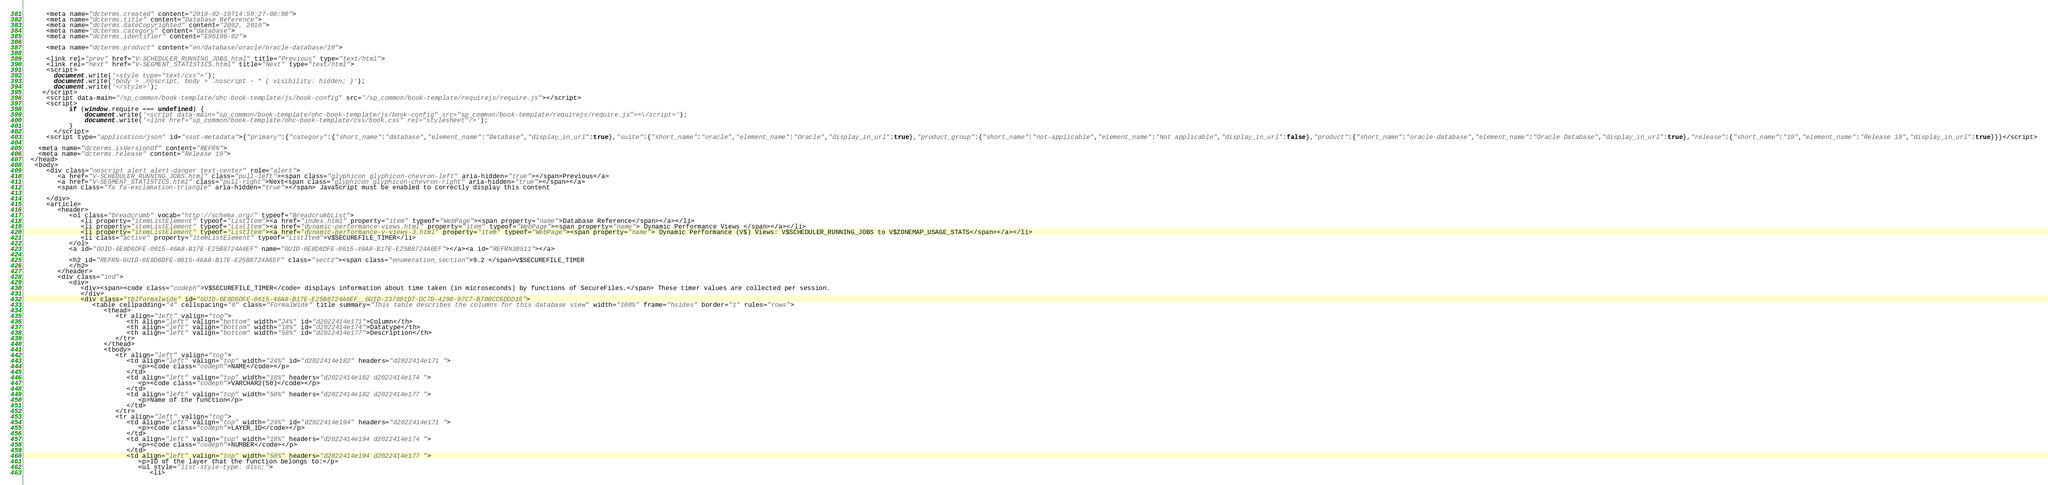<code> <loc_0><loc_0><loc_500><loc_500><_HTML_>      <meta name="dcterms.created" content="2019-02-10T14:59:27-08:00">
      <meta name="dcterms.title" content="Database Reference">
      <meta name="dcterms.dateCopyrighted" content="2002, 2019">
      <meta name="dcterms.category" content="database">
      <meta name="dcterms.identifier" content="E96196-02">
      
      <meta name="dcterms.product" content="en/database/oracle/oracle-database/19">
      
      <link rel="prev" href="V-SCHEDULER_RUNNING_JOBS.html" title="Previous" type="text/html">
      <link rel="next" href="V-SEGMENT_STATISTICS.html" title="Next" type="text/html">
      <script>
        document.write('<style type="text/css">');
        document.write('body > .noscript, body > .noscript ~ * { visibility: hidden; }');
        document.write('</style>');
     </script>
      <script data-main="/sp_common/book-template/ohc-book-template/js/book-config" src="/sp_common/book-template/requirejs/require.js"></script>
      <script>
            if (window.require === undefined) {
                document.write('<script data-main="sp_common/book-template/ohc-book-template/js/book-config" src="sp_common/book-template/requirejs/require.js"><\/script>');
                document.write('<link href="sp_common/book-template/ohc-book-template/css/book.css" rel="stylesheet"/>');
            }
        </script>
      <script type="application/json" id="ssot-metadata">{"primary":{"category":{"short_name":"database","element_name":"Database","display_in_url":true},"suite":{"short_name":"oracle","element_name":"Oracle","display_in_url":true},"product_group":{"short_name":"not-applicable","element_name":"Not applicable","display_in_url":false},"product":{"short_name":"oracle-database","element_name":"Oracle Database","display_in_url":true},"release":{"short_name":"19","element_name":"Release 19","display_in_url":true}}}</script>
      
    <meta name="dcterms.isVersionOf" content="REFRN">
    <meta name="dcterms.release" content="Release 19">
  </head>
   <body>
      <div class="noscript alert alert-danger text-center" role="alert">
         <a href="V-SCHEDULER_RUNNING_JOBS.html" class="pull-left"><span class="glyphicon glyphicon-chevron-left" aria-hidden="true"></span>Previous</a>
         <a href="V-SEGMENT_STATISTICS.html" class="pull-right">Next<span class="glyphicon glyphicon-chevron-right" aria-hidden="true"></span></a>
         <span class="fa fa-exclamation-triangle" aria-hidden="true"></span> JavaScript must be enabled to correctly display this content
        
      </div>
      <article>
         <header>
            <ol class="breadcrumb" vocab="http://schema.org/" typeof="BreadcrumbList">
               <li property="itemListElement" typeof="ListItem"><a href="index.html" property="item" typeof="WebPage"><span property="name">Database Reference</span></a></li>
               <li property="itemListElement" typeof="ListItem"><a href="dynamic-performance-views.html" property="item" typeof="WebPage"><span property="name"> Dynamic Performance Views </span></a></li>
               <li property="itemListElement" typeof="ListItem"><a href="dynamic-performance-v-views-3.html" property="item" typeof="WebPage"><span property="name"> Dynamic Performance (V$) Views: V$SCHEDULER_RUNNING_JOBS to V$ZONEMAP_USAGE_STATS</span></a></li>
               <li class="active" property="itemListElement" typeof="ListItem">V$SECUREFILE_TIMER</li>
            </ol>
            <a id="GUID-6E8D6DFE-0615-46A8-B17E-E25B8724A6EF" name="GUID-6E8D6DFE-0615-46A8-B17E-E25B8724A6EF"></a><a id="REFRN30511"></a>
            
            <h2 id="REFRN-GUID-6E8D6DFE-0615-46A8-B17E-E25B8724A6EF" class="sect2"><span class="enumeration_section">9.2 </span>V$SECUREFILE_TIMER
            </h2>
         </header>
         <div class="ind">
            <div>
               <div><span><code class="codeph">V$SECUREFILE_TIMER</code> displays information about time taken (in microseconds) by functions of SecureFiles.</span> These timer values are collected per session.
               </div>
               <div class="tblformalwide" id="GUID-6E8D6DFE-0615-46A8-B17E-E25B8724A6EF__GUID-237801D7-DC7D-4290-97C7-B700CC6DDD15">
                  <table cellpadding="4" cellspacing="0" class="FormalWide" title summary="This table describes the columns for this database view" width="100%" frame="hsides" border="1" rules="rows">
                     <thead>
                        <tr align="left" valign="top">
                           <th align="left" valign="bottom" width="24%" id="d2022414e171">Column</th>
                           <th align="left" valign="bottom" width="18%" id="d2022414e174">Datatype</th>
                           <th align="left" valign="bottom" width="58%" id="d2022414e177">Description</th>
                        </tr>
                     </thead>
                     <tbody>
                        <tr align="left" valign="top">
                           <td align="left" valign="top" width="24%" id="d2022414e182" headers="d2022414e171 ">
                              <p><code class="codeph">NAME</code></p>
                           </td>
                           <td align="left" valign="top" width="18%" headers="d2022414e182 d2022414e174 ">
                              <p><code class="codeph">VARCHAR2(50)</code></p>
                           </td>
                           <td align="left" valign="top" width="58%" headers="d2022414e182 d2022414e177 ">
                              <p>Name of the function</p>
                           </td>
                        </tr>
                        <tr align="left" valign="top">
                           <td align="left" valign="top" width="24%" id="d2022414e194" headers="d2022414e171 ">
                              <p><code class="codeph">LAYER_ID</code></p>
                           </td>
                           <td align="left" valign="top" width="18%" headers="d2022414e194 d2022414e174 ">
                              <p><code class="codeph">NUMBER</code></p>
                           </td>
                           <td align="left" valign="top" width="58%" headers="d2022414e194 d2022414e177 ">
                              <p>ID of the layer that the function belongs to:</p>
                              <ul style="list-style-type: disc;">
                                 <li></code> 